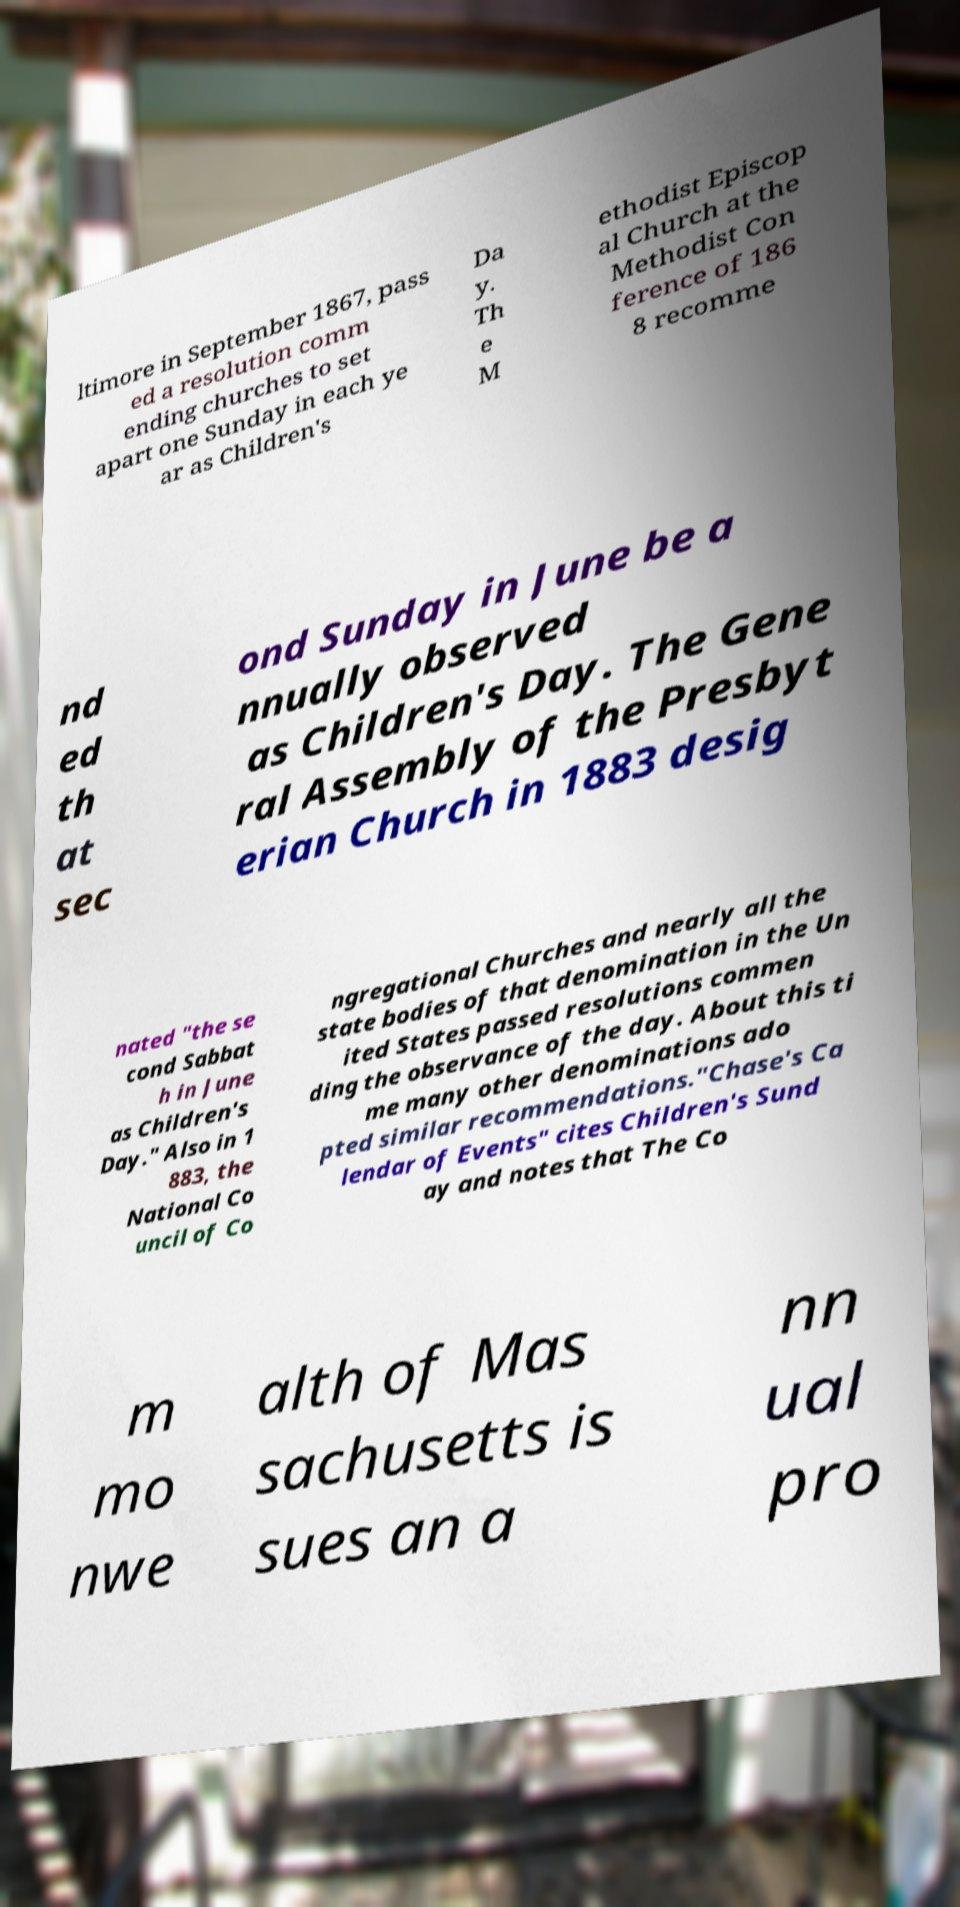Please read and relay the text visible in this image. What does it say? ltimore in September 1867, pass ed a resolution comm ending churches to set apart one Sunday in each ye ar as Children's Da y. Th e M ethodist Episcop al Church at the Methodist Con ference of 186 8 recomme nd ed th at sec ond Sunday in June be a nnually observed as Children's Day. The Gene ral Assembly of the Presbyt erian Church in 1883 desig nated "the se cond Sabbat h in June as Children's Day." Also in 1 883, the National Co uncil of Co ngregational Churches and nearly all the state bodies of that denomination in the Un ited States passed resolutions commen ding the observance of the day. About this ti me many other denominations ado pted similar recommendations."Chase's Ca lendar of Events" cites Children's Sund ay and notes that The Co m mo nwe alth of Mas sachusetts is sues an a nn ual pro 